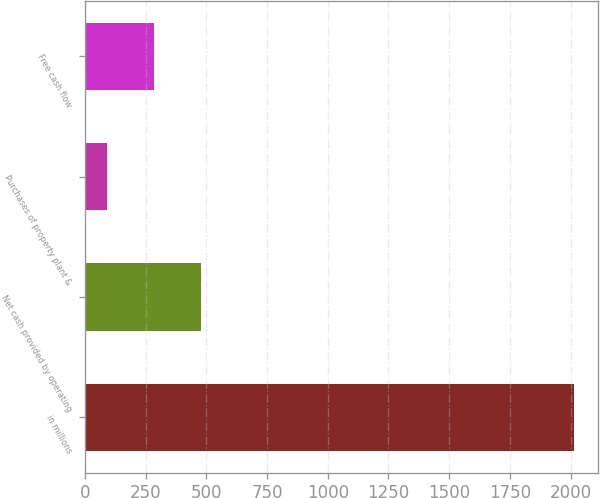<chart> <loc_0><loc_0><loc_500><loc_500><bar_chart><fcel>in millions<fcel>Net cash provided by operating<fcel>Purchases of property plant &<fcel>Free cash flow<nl><fcel>2012<fcel>477.12<fcel>93.4<fcel>285.26<nl></chart> 